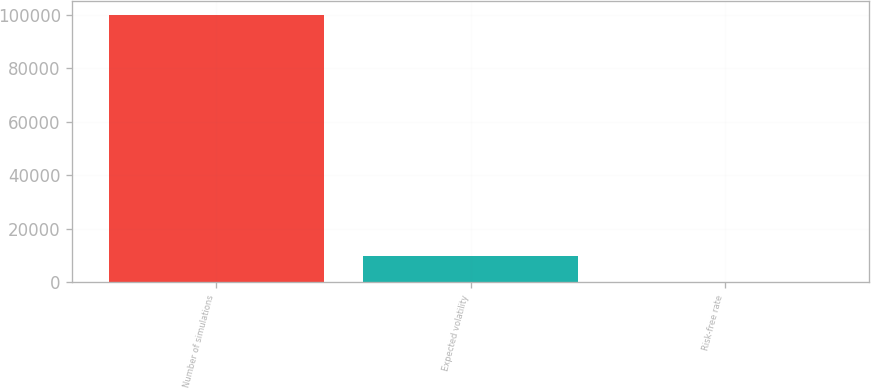Convert chart. <chart><loc_0><loc_0><loc_500><loc_500><bar_chart><fcel>Number of simulations<fcel>Expected volatility<fcel>Risk-free rate<nl><fcel>100000<fcel>10003<fcel>3.3<nl></chart> 